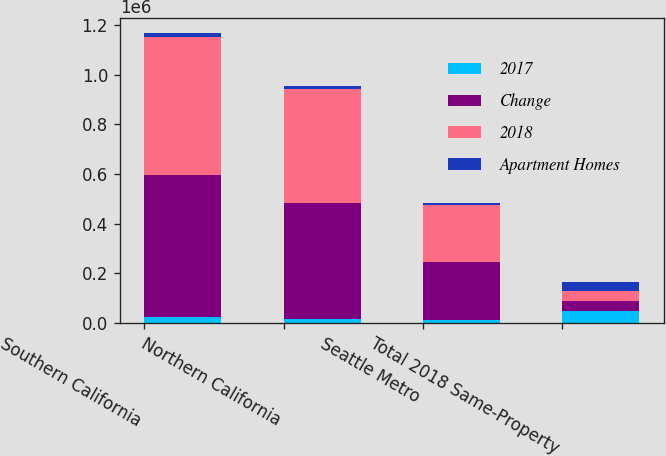Convert chart to OTSL. <chart><loc_0><loc_0><loc_500><loc_500><stacked_bar_chart><ecel><fcel>Southern California<fcel>Northern California<fcel>Seattle Metro<fcel>Total 2018 Same-Property<nl><fcel>2017<fcel>21979<fcel>14356<fcel>10238<fcel>46573<nl><fcel>Change<fcel>573658<fcel>469457<fcel>236525<fcel>40735<nl><fcel>2018<fcel>556630<fcel>458241<fcel>229872<fcel>40735<nl><fcel>Apartment Homes<fcel>17028<fcel>11216<fcel>6653<fcel>34897<nl></chart> 